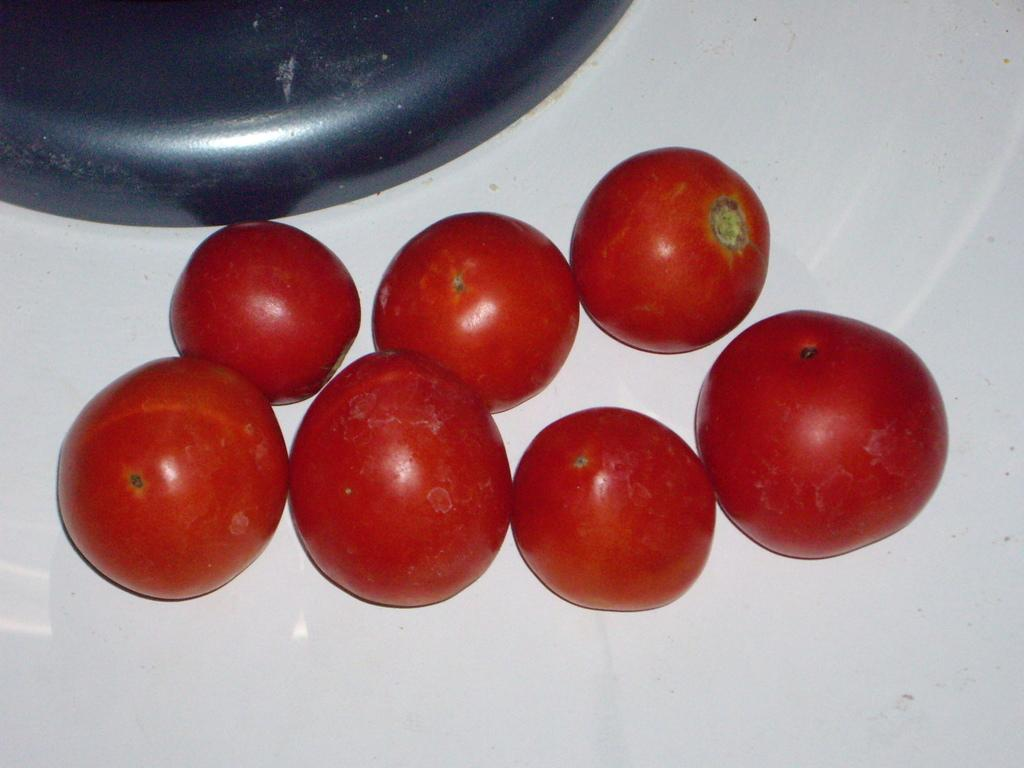How many tomatoes are visible in the foreground of the image? There are seven tomatoes in the foreground of the image. What is the color of the surface on which the tomatoes are placed? The tomatoes are on a white surface. Can you describe the object located at the top of the image? There is a black colored object on the top of the image. What advice is the mother giving to the tomatoes in the image? There is no mother or advice-giving in the image; it only features tomatoes on a white surface and a black colored object at the top. 